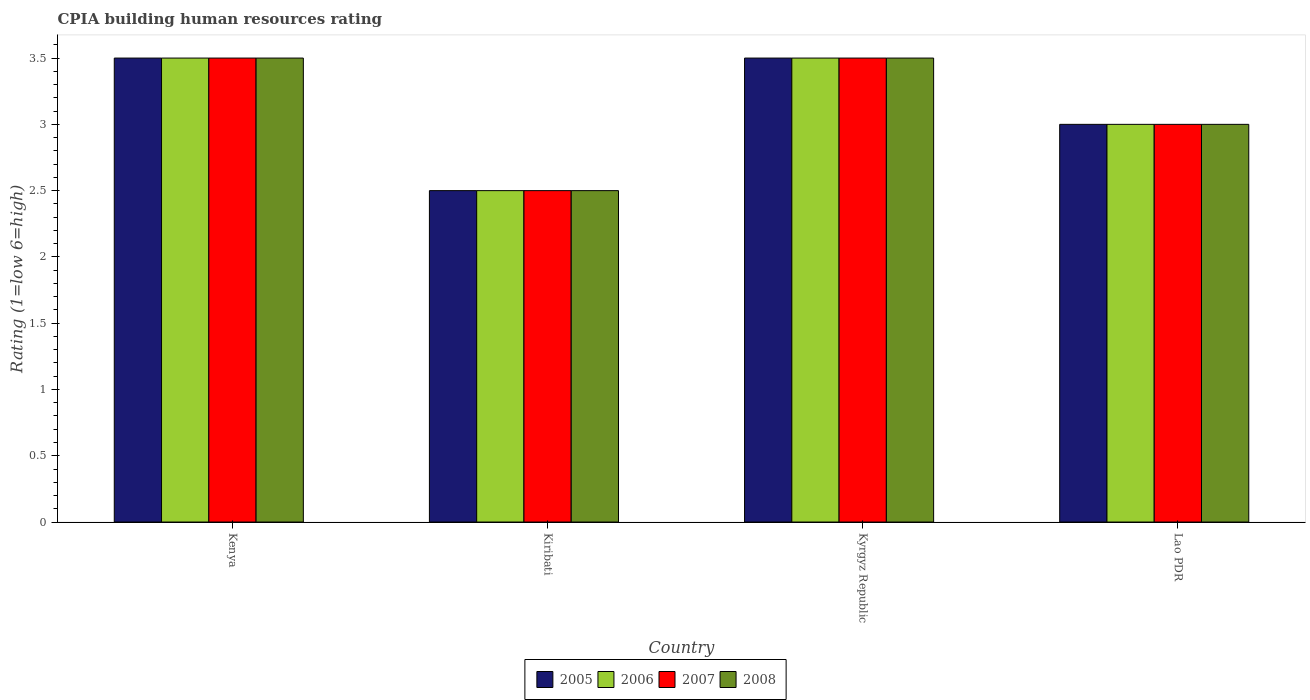How many different coloured bars are there?
Your response must be concise. 4. How many groups of bars are there?
Ensure brevity in your answer.  4. Are the number of bars per tick equal to the number of legend labels?
Ensure brevity in your answer.  Yes. Are the number of bars on each tick of the X-axis equal?
Offer a very short reply. Yes. What is the label of the 4th group of bars from the left?
Make the answer very short. Lao PDR. In which country was the CPIA rating in 2005 maximum?
Your answer should be very brief. Kenya. In which country was the CPIA rating in 2008 minimum?
Offer a very short reply. Kiribati. What is the total CPIA rating in 2006 in the graph?
Ensure brevity in your answer.  12.5. What is the difference between the CPIA rating in 2007 in Kyrgyz Republic and that in Lao PDR?
Offer a very short reply. 0.5. What is the difference between the CPIA rating in 2005 in Kenya and the CPIA rating in 2007 in Lao PDR?
Make the answer very short. 0.5. What is the average CPIA rating in 2008 per country?
Give a very brief answer. 3.12. What is the ratio of the CPIA rating in 2005 in Kyrgyz Republic to that in Lao PDR?
Give a very brief answer. 1.17. What is the difference between the highest and the second highest CPIA rating in 2007?
Provide a succinct answer. -0.5. Is the sum of the CPIA rating in 2007 in Kenya and Kiribati greater than the maximum CPIA rating in 2005 across all countries?
Offer a terse response. Yes. Is it the case that in every country, the sum of the CPIA rating in 2005 and CPIA rating in 2007 is greater than the sum of CPIA rating in 2008 and CPIA rating in 2006?
Provide a succinct answer. No. What does the 2nd bar from the right in Kiribati represents?
Your response must be concise. 2007. Is it the case that in every country, the sum of the CPIA rating in 2008 and CPIA rating in 2006 is greater than the CPIA rating in 2005?
Make the answer very short. Yes. How many bars are there?
Your answer should be compact. 16. Are all the bars in the graph horizontal?
Keep it short and to the point. No. Are the values on the major ticks of Y-axis written in scientific E-notation?
Offer a terse response. No. How are the legend labels stacked?
Offer a very short reply. Horizontal. What is the title of the graph?
Offer a very short reply. CPIA building human resources rating. Does "1976" appear as one of the legend labels in the graph?
Your response must be concise. No. What is the label or title of the X-axis?
Your answer should be very brief. Country. What is the label or title of the Y-axis?
Offer a very short reply. Rating (1=low 6=high). What is the Rating (1=low 6=high) of 2006 in Kenya?
Give a very brief answer. 3.5. What is the Rating (1=low 6=high) of 2007 in Kiribati?
Your answer should be very brief. 2.5. What is the Rating (1=low 6=high) in 2005 in Kyrgyz Republic?
Give a very brief answer. 3.5. What is the Rating (1=low 6=high) of 2008 in Kyrgyz Republic?
Keep it short and to the point. 3.5. What is the Rating (1=low 6=high) of 2007 in Lao PDR?
Ensure brevity in your answer.  3. What is the Rating (1=low 6=high) of 2008 in Lao PDR?
Keep it short and to the point. 3. Across all countries, what is the maximum Rating (1=low 6=high) of 2006?
Ensure brevity in your answer.  3.5. Across all countries, what is the maximum Rating (1=low 6=high) of 2007?
Your answer should be compact. 3.5. Across all countries, what is the minimum Rating (1=low 6=high) in 2006?
Provide a short and direct response. 2.5. Across all countries, what is the minimum Rating (1=low 6=high) in 2008?
Your answer should be compact. 2.5. What is the total Rating (1=low 6=high) of 2007 in the graph?
Provide a short and direct response. 12.5. What is the difference between the Rating (1=low 6=high) of 2005 in Kenya and that in Kiribati?
Offer a very short reply. 1. What is the difference between the Rating (1=low 6=high) of 2006 in Kenya and that in Kiribati?
Make the answer very short. 1. What is the difference between the Rating (1=low 6=high) of 2007 in Kenya and that in Kiribati?
Give a very brief answer. 1. What is the difference between the Rating (1=low 6=high) in 2008 in Kenya and that in Kiribati?
Offer a very short reply. 1. What is the difference between the Rating (1=low 6=high) in 2006 in Kenya and that in Kyrgyz Republic?
Provide a succinct answer. 0. What is the difference between the Rating (1=low 6=high) in 2007 in Kenya and that in Kyrgyz Republic?
Your answer should be compact. 0. What is the difference between the Rating (1=low 6=high) in 2006 in Kenya and that in Lao PDR?
Keep it short and to the point. 0.5. What is the difference between the Rating (1=low 6=high) in 2008 in Kenya and that in Lao PDR?
Provide a succinct answer. 0.5. What is the difference between the Rating (1=low 6=high) in 2006 in Kiribati and that in Kyrgyz Republic?
Offer a terse response. -1. What is the difference between the Rating (1=low 6=high) of 2007 in Kiribati and that in Kyrgyz Republic?
Keep it short and to the point. -1. What is the difference between the Rating (1=low 6=high) in 2007 in Kiribati and that in Lao PDR?
Offer a very short reply. -0.5. What is the difference between the Rating (1=low 6=high) in 2005 in Kenya and the Rating (1=low 6=high) in 2006 in Kiribati?
Offer a terse response. 1. What is the difference between the Rating (1=low 6=high) of 2005 in Kenya and the Rating (1=low 6=high) of 2008 in Kiribati?
Ensure brevity in your answer.  1. What is the difference between the Rating (1=low 6=high) in 2007 in Kenya and the Rating (1=low 6=high) in 2008 in Kiribati?
Offer a terse response. 1. What is the difference between the Rating (1=low 6=high) in 2005 in Kenya and the Rating (1=low 6=high) in 2006 in Kyrgyz Republic?
Offer a terse response. 0. What is the difference between the Rating (1=low 6=high) in 2005 in Kenya and the Rating (1=low 6=high) in 2007 in Kyrgyz Republic?
Offer a very short reply. 0. What is the difference between the Rating (1=low 6=high) in 2007 in Kenya and the Rating (1=low 6=high) in 2008 in Kyrgyz Republic?
Provide a succinct answer. 0. What is the difference between the Rating (1=low 6=high) in 2005 in Kenya and the Rating (1=low 6=high) in 2006 in Lao PDR?
Give a very brief answer. 0.5. What is the difference between the Rating (1=low 6=high) in 2005 in Kenya and the Rating (1=low 6=high) in 2007 in Lao PDR?
Your answer should be compact. 0.5. What is the difference between the Rating (1=low 6=high) of 2006 in Kenya and the Rating (1=low 6=high) of 2007 in Lao PDR?
Provide a short and direct response. 0.5. What is the difference between the Rating (1=low 6=high) in 2006 in Kenya and the Rating (1=low 6=high) in 2008 in Lao PDR?
Your answer should be very brief. 0.5. What is the difference between the Rating (1=low 6=high) of 2007 in Kenya and the Rating (1=low 6=high) of 2008 in Lao PDR?
Give a very brief answer. 0.5. What is the difference between the Rating (1=low 6=high) of 2006 in Kiribati and the Rating (1=low 6=high) of 2008 in Kyrgyz Republic?
Your response must be concise. -1. What is the difference between the Rating (1=low 6=high) in 2005 in Kiribati and the Rating (1=low 6=high) in 2006 in Lao PDR?
Offer a very short reply. -0.5. What is the difference between the Rating (1=low 6=high) in 2005 in Kiribati and the Rating (1=low 6=high) in 2007 in Lao PDR?
Ensure brevity in your answer.  -0.5. What is the difference between the Rating (1=low 6=high) in 2005 in Kiribati and the Rating (1=low 6=high) in 2008 in Lao PDR?
Offer a terse response. -0.5. What is the difference between the Rating (1=low 6=high) of 2006 in Kiribati and the Rating (1=low 6=high) of 2007 in Lao PDR?
Your answer should be compact. -0.5. What is the difference between the Rating (1=low 6=high) in 2006 in Kiribati and the Rating (1=low 6=high) in 2008 in Lao PDR?
Provide a short and direct response. -0.5. What is the difference between the Rating (1=low 6=high) in 2005 in Kyrgyz Republic and the Rating (1=low 6=high) in 2008 in Lao PDR?
Ensure brevity in your answer.  0.5. What is the difference between the Rating (1=low 6=high) in 2006 in Kyrgyz Republic and the Rating (1=low 6=high) in 2008 in Lao PDR?
Offer a terse response. 0.5. What is the average Rating (1=low 6=high) in 2005 per country?
Keep it short and to the point. 3.12. What is the average Rating (1=low 6=high) of 2006 per country?
Give a very brief answer. 3.12. What is the average Rating (1=low 6=high) in 2007 per country?
Make the answer very short. 3.12. What is the average Rating (1=low 6=high) of 2008 per country?
Provide a short and direct response. 3.12. What is the difference between the Rating (1=low 6=high) in 2005 and Rating (1=low 6=high) in 2006 in Kenya?
Keep it short and to the point. 0. What is the difference between the Rating (1=low 6=high) of 2005 and Rating (1=low 6=high) of 2008 in Kenya?
Keep it short and to the point. 0. What is the difference between the Rating (1=low 6=high) of 2006 and Rating (1=low 6=high) of 2007 in Kenya?
Your answer should be very brief. 0. What is the difference between the Rating (1=low 6=high) in 2005 and Rating (1=low 6=high) in 2006 in Kiribati?
Your answer should be very brief. 0. What is the difference between the Rating (1=low 6=high) of 2005 and Rating (1=low 6=high) of 2007 in Kiribati?
Make the answer very short. 0. What is the difference between the Rating (1=low 6=high) of 2005 and Rating (1=low 6=high) of 2008 in Kiribati?
Provide a succinct answer. 0. What is the difference between the Rating (1=low 6=high) of 2006 and Rating (1=low 6=high) of 2007 in Kiribati?
Provide a succinct answer. 0. What is the difference between the Rating (1=low 6=high) in 2005 and Rating (1=low 6=high) in 2008 in Kyrgyz Republic?
Keep it short and to the point. 0. What is the difference between the Rating (1=low 6=high) of 2005 and Rating (1=low 6=high) of 2006 in Lao PDR?
Ensure brevity in your answer.  0. What is the difference between the Rating (1=low 6=high) of 2005 and Rating (1=low 6=high) of 2008 in Lao PDR?
Make the answer very short. 0. What is the difference between the Rating (1=low 6=high) in 2006 and Rating (1=low 6=high) in 2007 in Lao PDR?
Keep it short and to the point. 0. What is the difference between the Rating (1=low 6=high) in 2007 and Rating (1=low 6=high) in 2008 in Lao PDR?
Keep it short and to the point. 0. What is the ratio of the Rating (1=low 6=high) of 2005 in Kenya to that in Kyrgyz Republic?
Provide a succinct answer. 1. What is the ratio of the Rating (1=low 6=high) of 2007 in Kenya to that in Kyrgyz Republic?
Give a very brief answer. 1. What is the ratio of the Rating (1=low 6=high) in 2008 in Kenya to that in Kyrgyz Republic?
Your answer should be very brief. 1. What is the ratio of the Rating (1=low 6=high) in 2005 in Kenya to that in Lao PDR?
Make the answer very short. 1.17. What is the ratio of the Rating (1=low 6=high) of 2006 in Kenya to that in Lao PDR?
Provide a short and direct response. 1.17. What is the ratio of the Rating (1=low 6=high) of 2007 in Kenya to that in Lao PDR?
Provide a succinct answer. 1.17. What is the ratio of the Rating (1=low 6=high) of 2008 in Kenya to that in Lao PDR?
Provide a short and direct response. 1.17. What is the ratio of the Rating (1=low 6=high) in 2006 in Kiribati to that in Kyrgyz Republic?
Your response must be concise. 0.71. What is the ratio of the Rating (1=low 6=high) of 2007 in Kiribati to that in Kyrgyz Republic?
Offer a terse response. 0.71. What is the ratio of the Rating (1=low 6=high) in 2007 in Kiribati to that in Lao PDR?
Make the answer very short. 0.83. What is the ratio of the Rating (1=low 6=high) in 2008 in Kiribati to that in Lao PDR?
Provide a succinct answer. 0.83. What is the ratio of the Rating (1=low 6=high) of 2005 in Kyrgyz Republic to that in Lao PDR?
Give a very brief answer. 1.17. What is the ratio of the Rating (1=low 6=high) in 2006 in Kyrgyz Republic to that in Lao PDR?
Give a very brief answer. 1.17. What is the ratio of the Rating (1=low 6=high) in 2007 in Kyrgyz Republic to that in Lao PDR?
Your response must be concise. 1.17. What is the ratio of the Rating (1=low 6=high) of 2008 in Kyrgyz Republic to that in Lao PDR?
Keep it short and to the point. 1.17. What is the difference between the highest and the second highest Rating (1=low 6=high) in 2007?
Keep it short and to the point. 0. What is the difference between the highest and the second highest Rating (1=low 6=high) of 2008?
Keep it short and to the point. 0. What is the difference between the highest and the lowest Rating (1=low 6=high) in 2005?
Give a very brief answer. 1. What is the difference between the highest and the lowest Rating (1=low 6=high) in 2007?
Ensure brevity in your answer.  1. 